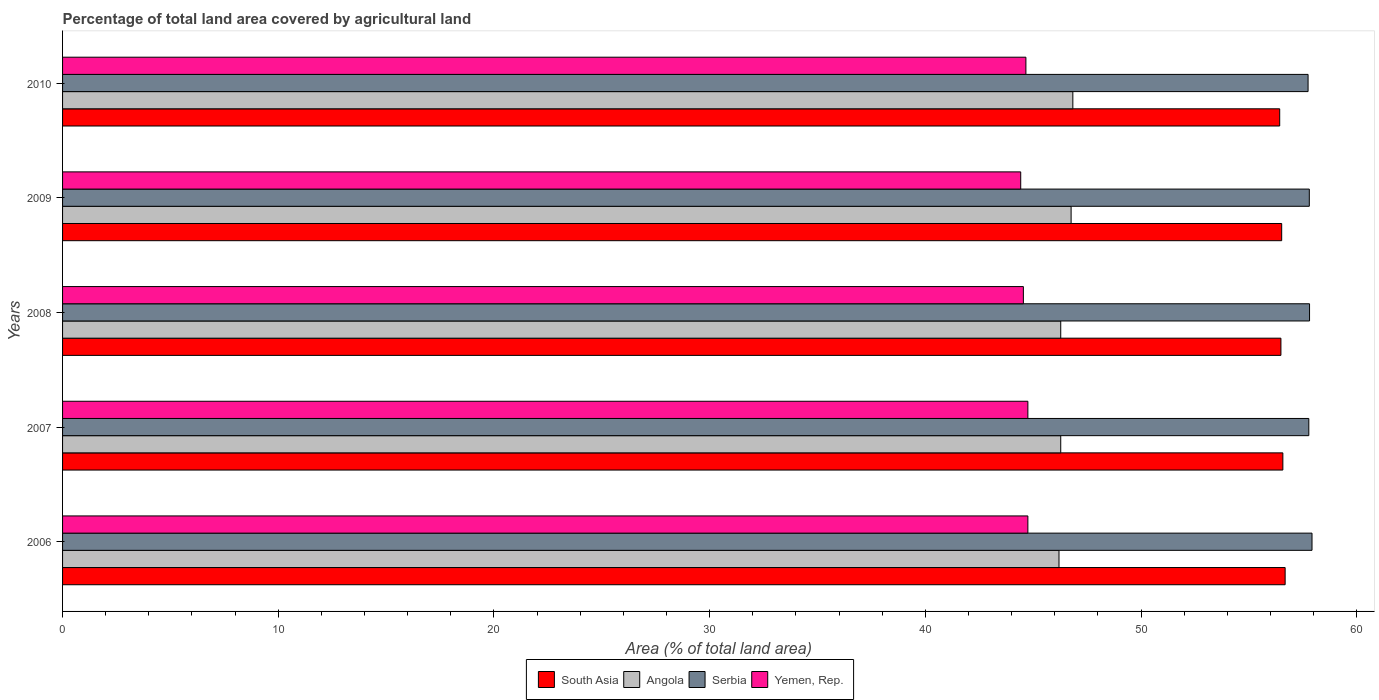How many different coloured bars are there?
Keep it short and to the point. 4. How many groups of bars are there?
Make the answer very short. 5. Are the number of bars per tick equal to the number of legend labels?
Provide a succinct answer. Yes. Are the number of bars on each tick of the Y-axis equal?
Offer a very short reply. Yes. How many bars are there on the 2nd tick from the top?
Offer a terse response. 4. How many bars are there on the 2nd tick from the bottom?
Offer a terse response. 4. In how many cases, is the number of bars for a given year not equal to the number of legend labels?
Your answer should be compact. 0. What is the percentage of agricultural land in South Asia in 2009?
Make the answer very short. 56.52. Across all years, what is the maximum percentage of agricultural land in Yemen, Rep.?
Make the answer very short. 44.75. Across all years, what is the minimum percentage of agricultural land in Angola?
Ensure brevity in your answer.  46.19. In which year was the percentage of agricultural land in Angola maximum?
Your response must be concise. 2010. In which year was the percentage of agricultural land in Yemen, Rep. minimum?
Your answer should be very brief. 2009. What is the total percentage of agricultural land in Angola in the graph?
Make the answer very short. 232.33. What is the difference between the percentage of agricultural land in Yemen, Rep. in 2006 and that in 2010?
Offer a terse response. 0.09. What is the difference between the percentage of agricultural land in Angola in 2010 and the percentage of agricultural land in Yemen, Rep. in 2008?
Your answer should be very brief. 2.29. What is the average percentage of agricultural land in Yemen, Rep. per year?
Your answer should be compact. 44.62. In the year 2007, what is the difference between the percentage of agricultural land in Serbia and percentage of agricultural land in Angola?
Keep it short and to the point. 11.5. In how many years, is the percentage of agricultural land in Angola greater than 40 %?
Provide a succinct answer. 5. What is the ratio of the percentage of agricultural land in Serbia in 2007 to that in 2008?
Provide a succinct answer. 1. Is the difference between the percentage of agricultural land in Serbia in 2006 and 2007 greater than the difference between the percentage of agricultural land in Angola in 2006 and 2007?
Make the answer very short. Yes. What is the difference between the highest and the second highest percentage of agricultural land in South Asia?
Give a very brief answer. 0.11. What is the difference between the highest and the lowest percentage of agricultural land in South Asia?
Your answer should be compact. 0.25. Is the sum of the percentage of agricultural land in Serbia in 2006 and 2009 greater than the maximum percentage of agricultural land in Angola across all years?
Offer a very short reply. Yes. Is it the case that in every year, the sum of the percentage of agricultural land in Yemen, Rep. and percentage of agricultural land in Serbia is greater than the sum of percentage of agricultural land in Angola and percentage of agricultural land in South Asia?
Offer a very short reply. Yes. What does the 2nd bar from the top in 2009 represents?
Your response must be concise. Serbia. What does the 3rd bar from the bottom in 2006 represents?
Your answer should be compact. Serbia. How many bars are there?
Keep it short and to the point. 20. How many years are there in the graph?
Your answer should be compact. 5. What is the difference between two consecutive major ticks on the X-axis?
Offer a very short reply. 10. Are the values on the major ticks of X-axis written in scientific E-notation?
Offer a terse response. No. Does the graph contain grids?
Offer a terse response. No. Where does the legend appear in the graph?
Make the answer very short. Bottom center. How are the legend labels stacked?
Your response must be concise. Horizontal. What is the title of the graph?
Offer a terse response. Percentage of total land area covered by agricultural land. Does "Costa Rica" appear as one of the legend labels in the graph?
Provide a short and direct response. No. What is the label or title of the X-axis?
Provide a short and direct response. Area (% of total land area). What is the label or title of the Y-axis?
Your answer should be compact. Years. What is the Area (% of total land area) of South Asia in 2006?
Your answer should be very brief. 56.68. What is the Area (% of total land area) of Angola in 2006?
Ensure brevity in your answer.  46.19. What is the Area (% of total land area) of Serbia in 2006?
Your answer should be compact. 57.92. What is the Area (% of total land area) of Yemen, Rep. in 2006?
Make the answer very short. 44.75. What is the Area (% of total land area) in South Asia in 2007?
Your response must be concise. 56.57. What is the Area (% of total land area) in Angola in 2007?
Your answer should be compact. 46.27. What is the Area (% of total land area) in Serbia in 2007?
Ensure brevity in your answer.  57.77. What is the Area (% of total land area) in Yemen, Rep. in 2007?
Your answer should be compact. 44.75. What is the Area (% of total land area) of South Asia in 2008?
Offer a very short reply. 56.48. What is the Area (% of total land area) of Angola in 2008?
Make the answer very short. 46.27. What is the Area (% of total land area) of Serbia in 2008?
Your response must be concise. 57.81. What is the Area (% of total land area) in Yemen, Rep. in 2008?
Your response must be concise. 44.54. What is the Area (% of total land area) of South Asia in 2009?
Make the answer very short. 56.52. What is the Area (% of total land area) in Angola in 2009?
Provide a short and direct response. 46.76. What is the Area (% of total land area) in Serbia in 2009?
Your answer should be very brief. 57.8. What is the Area (% of total land area) of Yemen, Rep. in 2009?
Keep it short and to the point. 44.42. What is the Area (% of total land area) of South Asia in 2010?
Provide a short and direct response. 56.43. What is the Area (% of total land area) in Angola in 2010?
Provide a short and direct response. 46.84. What is the Area (% of total land area) of Serbia in 2010?
Your response must be concise. 57.74. What is the Area (% of total land area) in Yemen, Rep. in 2010?
Provide a short and direct response. 44.66. Across all years, what is the maximum Area (% of total land area) of South Asia?
Your answer should be very brief. 56.68. Across all years, what is the maximum Area (% of total land area) of Angola?
Provide a succinct answer. 46.84. Across all years, what is the maximum Area (% of total land area) in Serbia?
Ensure brevity in your answer.  57.92. Across all years, what is the maximum Area (% of total land area) in Yemen, Rep.?
Your answer should be very brief. 44.75. Across all years, what is the minimum Area (% of total land area) in South Asia?
Your answer should be very brief. 56.43. Across all years, what is the minimum Area (% of total land area) in Angola?
Give a very brief answer. 46.19. Across all years, what is the minimum Area (% of total land area) of Serbia?
Provide a succinct answer. 57.74. Across all years, what is the minimum Area (% of total land area) of Yemen, Rep.?
Keep it short and to the point. 44.42. What is the total Area (% of total land area) of South Asia in the graph?
Keep it short and to the point. 282.67. What is the total Area (% of total land area) in Angola in the graph?
Ensure brevity in your answer.  232.33. What is the total Area (% of total land area) in Serbia in the graph?
Make the answer very short. 289.05. What is the total Area (% of total land area) of Yemen, Rep. in the graph?
Offer a terse response. 223.12. What is the difference between the Area (% of total land area) of South Asia in 2006 and that in 2007?
Your answer should be very brief. 0.11. What is the difference between the Area (% of total land area) in Angola in 2006 and that in 2007?
Your response must be concise. -0.08. What is the difference between the Area (% of total land area) in Serbia in 2006 and that in 2007?
Offer a very short reply. 0.15. What is the difference between the Area (% of total land area) of Yemen, Rep. in 2006 and that in 2007?
Give a very brief answer. 0. What is the difference between the Area (% of total land area) of South Asia in 2006 and that in 2008?
Provide a succinct answer. 0.2. What is the difference between the Area (% of total land area) of Angola in 2006 and that in 2008?
Keep it short and to the point. -0.08. What is the difference between the Area (% of total land area) in Serbia in 2006 and that in 2008?
Your answer should be very brief. 0.11. What is the difference between the Area (% of total land area) in Yemen, Rep. in 2006 and that in 2008?
Give a very brief answer. 0.21. What is the difference between the Area (% of total land area) of South Asia in 2006 and that in 2009?
Make the answer very short. 0.16. What is the difference between the Area (% of total land area) in Angola in 2006 and that in 2009?
Provide a short and direct response. -0.56. What is the difference between the Area (% of total land area) of Serbia in 2006 and that in 2009?
Keep it short and to the point. 0.13. What is the difference between the Area (% of total land area) in Yemen, Rep. in 2006 and that in 2009?
Offer a terse response. 0.33. What is the difference between the Area (% of total land area) of South Asia in 2006 and that in 2010?
Provide a short and direct response. 0.25. What is the difference between the Area (% of total land area) in Angola in 2006 and that in 2010?
Offer a terse response. -0.64. What is the difference between the Area (% of total land area) in Serbia in 2006 and that in 2010?
Your answer should be compact. 0.18. What is the difference between the Area (% of total land area) in Yemen, Rep. in 2006 and that in 2010?
Offer a very short reply. 0.09. What is the difference between the Area (% of total land area) of South Asia in 2007 and that in 2008?
Ensure brevity in your answer.  0.09. What is the difference between the Area (% of total land area) in Serbia in 2007 and that in 2008?
Provide a succinct answer. -0.03. What is the difference between the Area (% of total land area) of Yemen, Rep. in 2007 and that in 2008?
Keep it short and to the point. 0.21. What is the difference between the Area (% of total land area) of South Asia in 2007 and that in 2009?
Your response must be concise. 0.05. What is the difference between the Area (% of total land area) of Angola in 2007 and that in 2009?
Keep it short and to the point. -0.48. What is the difference between the Area (% of total land area) of Serbia in 2007 and that in 2009?
Ensure brevity in your answer.  -0.02. What is the difference between the Area (% of total land area) in Yemen, Rep. in 2007 and that in 2009?
Ensure brevity in your answer.  0.33. What is the difference between the Area (% of total land area) of South Asia in 2007 and that in 2010?
Offer a very short reply. 0.15. What is the difference between the Area (% of total land area) of Angola in 2007 and that in 2010?
Keep it short and to the point. -0.56. What is the difference between the Area (% of total land area) of Serbia in 2007 and that in 2010?
Your response must be concise. 0.03. What is the difference between the Area (% of total land area) of Yemen, Rep. in 2007 and that in 2010?
Provide a succinct answer. 0.09. What is the difference between the Area (% of total land area) of South Asia in 2008 and that in 2009?
Provide a succinct answer. -0.04. What is the difference between the Area (% of total land area) of Angola in 2008 and that in 2009?
Offer a very short reply. -0.48. What is the difference between the Area (% of total land area) in Serbia in 2008 and that in 2009?
Provide a succinct answer. 0.01. What is the difference between the Area (% of total land area) in Yemen, Rep. in 2008 and that in 2009?
Ensure brevity in your answer.  0.12. What is the difference between the Area (% of total land area) of South Asia in 2008 and that in 2010?
Your answer should be very brief. 0.06. What is the difference between the Area (% of total land area) of Angola in 2008 and that in 2010?
Provide a succinct answer. -0.56. What is the difference between the Area (% of total land area) in Serbia in 2008 and that in 2010?
Your response must be concise. 0.07. What is the difference between the Area (% of total land area) in Yemen, Rep. in 2008 and that in 2010?
Your response must be concise. -0.12. What is the difference between the Area (% of total land area) in South Asia in 2009 and that in 2010?
Ensure brevity in your answer.  0.09. What is the difference between the Area (% of total land area) in Angola in 2009 and that in 2010?
Provide a succinct answer. -0.08. What is the difference between the Area (% of total land area) of Serbia in 2009 and that in 2010?
Provide a succinct answer. 0.06. What is the difference between the Area (% of total land area) of Yemen, Rep. in 2009 and that in 2010?
Your answer should be very brief. -0.24. What is the difference between the Area (% of total land area) of South Asia in 2006 and the Area (% of total land area) of Angola in 2007?
Keep it short and to the point. 10.4. What is the difference between the Area (% of total land area) in South Asia in 2006 and the Area (% of total land area) in Serbia in 2007?
Keep it short and to the point. -1.1. What is the difference between the Area (% of total land area) of South Asia in 2006 and the Area (% of total land area) of Yemen, Rep. in 2007?
Offer a terse response. 11.93. What is the difference between the Area (% of total land area) of Angola in 2006 and the Area (% of total land area) of Serbia in 2007?
Your answer should be compact. -11.58. What is the difference between the Area (% of total land area) in Angola in 2006 and the Area (% of total land area) in Yemen, Rep. in 2007?
Provide a succinct answer. 1.44. What is the difference between the Area (% of total land area) in Serbia in 2006 and the Area (% of total land area) in Yemen, Rep. in 2007?
Provide a succinct answer. 13.17. What is the difference between the Area (% of total land area) in South Asia in 2006 and the Area (% of total land area) in Angola in 2008?
Your answer should be compact. 10.4. What is the difference between the Area (% of total land area) in South Asia in 2006 and the Area (% of total land area) in Serbia in 2008?
Offer a very short reply. -1.13. What is the difference between the Area (% of total land area) of South Asia in 2006 and the Area (% of total land area) of Yemen, Rep. in 2008?
Make the answer very short. 12.14. What is the difference between the Area (% of total land area) of Angola in 2006 and the Area (% of total land area) of Serbia in 2008?
Your response must be concise. -11.62. What is the difference between the Area (% of total land area) in Angola in 2006 and the Area (% of total land area) in Yemen, Rep. in 2008?
Your answer should be compact. 1.65. What is the difference between the Area (% of total land area) in Serbia in 2006 and the Area (% of total land area) in Yemen, Rep. in 2008?
Provide a succinct answer. 13.38. What is the difference between the Area (% of total land area) of South Asia in 2006 and the Area (% of total land area) of Angola in 2009?
Keep it short and to the point. 9.92. What is the difference between the Area (% of total land area) in South Asia in 2006 and the Area (% of total land area) in Serbia in 2009?
Your answer should be compact. -1.12. What is the difference between the Area (% of total land area) in South Asia in 2006 and the Area (% of total land area) in Yemen, Rep. in 2009?
Give a very brief answer. 12.26. What is the difference between the Area (% of total land area) in Angola in 2006 and the Area (% of total land area) in Serbia in 2009?
Ensure brevity in your answer.  -11.6. What is the difference between the Area (% of total land area) in Angola in 2006 and the Area (% of total land area) in Yemen, Rep. in 2009?
Provide a short and direct response. 1.77. What is the difference between the Area (% of total land area) of Serbia in 2006 and the Area (% of total land area) of Yemen, Rep. in 2009?
Make the answer very short. 13.5. What is the difference between the Area (% of total land area) in South Asia in 2006 and the Area (% of total land area) in Angola in 2010?
Offer a very short reply. 9.84. What is the difference between the Area (% of total land area) in South Asia in 2006 and the Area (% of total land area) in Serbia in 2010?
Offer a terse response. -1.06. What is the difference between the Area (% of total land area) of South Asia in 2006 and the Area (% of total land area) of Yemen, Rep. in 2010?
Provide a short and direct response. 12.02. What is the difference between the Area (% of total land area) of Angola in 2006 and the Area (% of total land area) of Serbia in 2010?
Provide a succinct answer. -11.55. What is the difference between the Area (% of total land area) of Angola in 2006 and the Area (% of total land area) of Yemen, Rep. in 2010?
Your response must be concise. 1.53. What is the difference between the Area (% of total land area) in Serbia in 2006 and the Area (% of total land area) in Yemen, Rep. in 2010?
Your answer should be very brief. 13.26. What is the difference between the Area (% of total land area) of South Asia in 2007 and the Area (% of total land area) of Angola in 2008?
Your answer should be compact. 10.3. What is the difference between the Area (% of total land area) of South Asia in 2007 and the Area (% of total land area) of Serbia in 2008?
Offer a terse response. -1.24. What is the difference between the Area (% of total land area) of South Asia in 2007 and the Area (% of total land area) of Yemen, Rep. in 2008?
Ensure brevity in your answer.  12.03. What is the difference between the Area (% of total land area) in Angola in 2007 and the Area (% of total land area) in Serbia in 2008?
Offer a terse response. -11.54. What is the difference between the Area (% of total land area) in Angola in 2007 and the Area (% of total land area) in Yemen, Rep. in 2008?
Keep it short and to the point. 1.73. What is the difference between the Area (% of total land area) in Serbia in 2007 and the Area (% of total land area) in Yemen, Rep. in 2008?
Ensure brevity in your answer.  13.23. What is the difference between the Area (% of total land area) of South Asia in 2007 and the Area (% of total land area) of Angola in 2009?
Provide a short and direct response. 9.82. What is the difference between the Area (% of total land area) in South Asia in 2007 and the Area (% of total land area) in Serbia in 2009?
Your answer should be very brief. -1.23. What is the difference between the Area (% of total land area) of South Asia in 2007 and the Area (% of total land area) of Yemen, Rep. in 2009?
Your response must be concise. 12.15. What is the difference between the Area (% of total land area) of Angola in 2007 and the Area (% of total land area) of Serbia in 2009?
Give a very brief answer. -11.52. What is the difference between the Area (% of total land area) of Angola in 2007 and the Area (% of total land area) of Yemen, Rep. in 2009?
Ensure brevity in your answer.  1.85. What is the difference between the Area (% of total land area) of Serbia in 2007 and the Area (% of total land area) of Yemen, Rep. in 2009?
Your response must be concise. 13.36. What is the difference between the Area (% of total land area) in South Asia in 2007 and the Area (% of total land area) in Angola in 2010?
Your answer should be compact. 9.74. What is the difference between the Area (% of total land area) in South Asia in 2007 and the Area (% of total land area) in Serbia in 2010?
Make the answer very short. -1.17. What is the difference between the Area (% of total land area) of South Asia in 2007 and the Area (% of total land area) of Yemen, Rep. in 2010?
Offer a very short reply. 11.91. What is the difference between the Area (% of total land area) in Angola in 2007 and the Area (% of total land area) in Serbia in 2010?
Offer a terse response. -11.47. What is the difference between the Area (% of total land area) of Angola in 2007 and the Area (% of total land area) of Yemen, Rep. in 2010?
Provide a succinct answer. 1.61. What is the difference between the Area (% of total land area) in Serbia in 2007 and the Area (% of total land area) in Yemen, Rep. in 2010?
Your answer should be compact. 13.12. What is the difference between the Area (% of total land area) of South Asia in 2008 and the Area (% of total land area) of Angola in 2009?
Offer a very short reply. 9.73. What is the difference between the Area (% of total land area) in South Asia in 2008 and the Area (% of total land area) in Serbia in 2009?
Your response must be concise. -1.32. What is the difference between the Area (% of total land area) in South Asia in 2008 and the Area (% of total land area) in Yemen, Rep. in 2009?
Keep it short and to the point. 12.06. What is the difference between the Area (% of total land area) of Angola in 2008 and the Area (% of total land area) of Serbia in 2009?
Your response must be concise. -11.52. What is the difference between the Area (% of total land area) of Angola in 2008 and the Area (% of total land area) of Yemen, Rep. in 2009?
Your answer should be compact. 1.85. What is the difference between the Area (% of total land area) of Serbia in 2008 and the Area (% of total land area) of Yemen, Rep. in 2009?
Offer a terse response. 13.39. What is the difference between the Area (% of total land area) in South Asia in 2008 and the Area (% of total land area) in Angola in 2010?
Make the answer very short. 9.65. What is the difference between the Area (% of total land area) in South Asia in 2008 and the Area (% of total land area) in Serbia in 2010?
Give a very brief answer. -1.26. What is the difference between the Area (% of total land area) of South Asia in 2008 and the Area (% of total land area) of Yemen, Rep. in 2010?
Ensure brevity in your answer.  11.82. What is the difference between the Area (% of total land area) in Angola in 2008 and the Area (% of total land area) in Serbia in 2010?
Give a very brief answer. -11.47. What is the difference between the Area (% of total land area) in Angola in 2008 and the Area (% of total land area) in Yemen, Rep. in 2010?
Offer a terse response. 1.61. What is the difference between the Area (% of total land area) of Serbia in 2008 and the Area (% of total land area) of Yemen, Rep. in 2010?
Provide a short and direct response. 13.15. What is the difference between the Area (% of total land area) of South Asia in 2009 and the Area (% of total land area) of Angola in 2010?
Offer a very short reply. 9.68. What is the difference between the Area (% of total land area) of South Asia in 2009 and the Area (% of total land area) of Serbia in 2010?
Offer a very short reply. -1.22. What is the difference between the Area (% of total land area) of South Asia in 2009 and the Area (% of total land area) of Yemen, Rep. in 2010?
Provide a succinct answer. 11.86. What is the difference between the Area (% of total land area) in Angola in 2009 and the Area (% of total land area) in Serbia in 2010?
Offer a terse response. -10.99. What is the difference between the Area (% of total land area) in Angola in 2009 and the Area (% of total land area) in Yemen, Rep. in 2010?
Your response must be concise. 2.1. What is the difference between the Area (% of total land area) in Serbia in 2009 and the Area (% of total land area) in Yemen, Rep. in 2010?
Offer a terse response. 13.14. What is the average Area (% of total land area) of South Asia per year?
Your answer should be compact. 56.53. What is the average Area (% of total land area) in Angola per year?
Offer a terse response. 46.47. What is the average Area (% of total land area) of Serbia per year?
Keep it short and to the point. 57.81. What is the average Area (% of total land area) of Yemen, Rep. per year?
Offer a very short reply. 44.62. In the year 2006, what is the difference between the Area (% of total land area) in South Asia and Area (% of total land area) in Angola?
Give a very brief answer. 10.48. In the year 2006, what is the difference between the Area (% of total land area) in South Asia and Area (% of total land area) in Serbia?
Give a very brief answer. -1.25. In the year 2006, what is the difference between the Area (% of total land area) in South Asia and Area (% of total land area) in Yemen, Rep.?
Keep it short and to the point. 11.93. In the year 2006, what is the difference between the Area (% of total land area) of Angola and Area (% of total land area) of Serbia?
Your answer should be compact. -11.73. In the year 2006, what is the difference between the Area (% of total land area) in Angola and Area (% of total land area) in Yemen, Rep.?
Your answer should be compact. 1.44. In the year 2006, what is the difference between the Area (% of total land area) of Serbia and Area (% of total land area) of Yemen, Rep.?
Offer a very short reply. 13.17. In the year 2007, what is the difference between the Area (% of total land area) in South Asia and Area (% of total land area) in Angola?
Provide a succinct answer. 10.3. In the year 2007, what is the difference between the Area (% of total land area) in South Asia and Area (% of total land area) in Serbia?
Provide a succinct answer. -1.2. In the year 2007, what is the difference between the Area (% of total land area) of South Asia and Area (% of total land area) of Yemen, Rep.?
Offer a very short reply. 11.82. In the year 2007, what is the difference between the Area (% of total land area) of Angola and Area (% of total land area) of Serbia?
Offer a terse response. -11.5. In the year 2007, what is the difference between the Area (% of total land area) of Angola and Area (% of total land area) of Yemen, Rep.?
Provide a short and direct response. 1.52. In the year 2007, what is the difference between the Area (% of total land area) of Serbia and Area (% of total land area) of Yemen, Rep.?
Your answer should be compact. 13.02. In the year 2008, what is the difference between the Area (% of total land area) of South Asia and Area (% of total land area) of Angola?
Ensure brevity in your answer.  10.21. In the year 2008, what is the difference between the Area (% of total land area) of South Asia and Area (% of total land area) of Serbia?
Offer a terse response. -1.33. In the year 2008, what is the difference between the Area (% of total land area) of South Asia and Area (% of total land area) of Yemen, Rep.?
Your answer should be very brief. 11.94. In the year 2008, what is the difference between the Area (% of total land area) in Angola and Area (% of total land area) in Serbia?
Keep it short and to the point. -11.54. In the year 2008, what is the difference between the Area (% of total land area) in Angola and Area (% of total land area) in Yemen, Rep.?
Make the answer very short. 1.73. In the year 2008, what is the difference between the Area (% of total land area) in Serbia and Area (% of total land area) in Yemen, Rep.?
Offer a very short reply. 13.27. In the year 2009, what is the difference between the Area (% of total land area) in South Asia and Area (% of total land area) in Angola?
Ensure brevity in your answer.  9.76. In the year 2009, what is the difference between the Area (% of total land area) in South Asia and Area (% of total land area) in Serbia?
Make the answer very short. -1.28. In the year 2009, what is the difference between the Area (% of total land area) in South Asia and Area (% of total land area) in Yemen, Rep.?
Your answer should be compact. 12.1. In the year 2009, what is the difference between the Area (% of total land area) of Angola and Area (% of total land area) of Serbia?
Provide a succinct answer. -11.04. In the year 2009, what is the difference between the Area (% of total land area) of Angola and Area (% of total land area) of Yemen, Rep.?
Keep it short and to the point. 2.34. In the year 2009, what is the difference between the Area (% of total land area) of Serbia and Area (% of total land area) of Yemen, Rep.?
Your answer should be compact. 13.38. In the year 2010, what is the difference between the Area (% of total land area) in South Asia and Area (% of total land area) in Angola?
Offer a terse response. 9.59. In the year 2010, what is the difference between the Area (% of total land area) in South Asia and Area (% of total land area) in Serbia?
Ensure brevity in your answer.  -1.31. In the year 2010, what is the difference between the Area (% of total land area) of South Asia and Area (% of total land area) of Yemen, Rep.?
Give a very brief answer. 11.77. In the year 2010, what is the difference between the Area (% of total land area) in Angola and Area (% of total land area) in Serbia?
Give a very brief answer. -10.9. In the year 2010, what is the difference between the Area (% of total land area) in Angola and Area (% of total land area) in Yemen, Rep.?
Keep it short and to the point. 2.18. In the year 2010, what is the difference between the Area (% of total land area) of Serbia and Area (% of total land area) of Yemen, Rep.?
Your answer should be compact. 13.08. What is the ratio of the Area (% of total land area) of South Asia in 2006 to that in 2007?
Make the answer very short. 1. What is the ratio of the Area (% of total land area) of Yemen, Rep. in 2006 to that in 2007?
Make the answer very short. 1. What is the ratio of the Area (% of total land area) of Angola in 2006 to that in 2008?
Offer a very short reply. 1. What is the ratio of the Area (% of total land area) of Yemen, Rep. in 2006 to that in 2008?
Ensure brevity in your answer.  1. What is the ratio of the Area (% of total land area) in South Asia in 2006 to that in 2009?
Your answer should be compact. 1. What is the ratio of the Area (% of total land area) in Serbia in 2006 to that in 2009?
Ensure brevity in your answer.  1. What is the ratio of the Area (% of total land area) of Yemen, Rep. in 2006 to that in 2009?
Provide a succinct answer. 1.01. What is the ratio of the Area (% of total land area) in South Asia in 2006 to that in 2010?
Your answer should be compact. 1. What is the ratio of the Area (% of total land area) of Angola in 2006 to that in 2010?
Provide a short and direct response. 0.99. What is the ratio of the Area (% of total land area) of Serbia in 2006 to that in 2010?
Your answer should be very brief. 1. What is the ratio of the Area (% of total land area) of South Asia in 2007 to that in 2008?
Your response must be concise. 1. What is the ratio of the Area (% of total land area) in Angola in 2007 to that in 2008?
Your answer should be very brief. 1. What is the ratio of the Area (% of total land area) of South Asia in 2007 to that in 2009?
Give a very brief answer. 1. What is the ratio of the Area (% of total land area) in Yemen, Rep. in 2007 to that in 2009?
Offer a very short reply. 1.01. What is the ratio of the Area (% of total land area) in South Asia in 2007 to that in 2010?
Your answer should be very brief. 1. What is the ratio of the Area (% of total land area) in Serbia in 2007 to that in 2010?
Your answer should be compact. 1. What is the ratio of the Area (% of total land area) of South Asia in 2008 to that in 2009?
Your response must be concise. 1. What is the ratio of the Area (% of total land area) in Angola in 2008 to that in 2009?
Make the answer very short. 0.99. What is the ratio of the Area (% of total land area) in Yemen, Rep. in 2008 to that in 2009?
Your answer should be very brief. 1. What is the ratio of the Area (% of total land area) in South Asia in 2009 to that in 2010?
Offer a terse response. 1. What is the ratio of the Area (% of total land area) in Yemen, Rep. in 2009 to that in 2010?
Your response must be concise. 0.99. What is the difference between the highest and the second highest Area (% of total land area) in South Asia?
Give a very brief answer. 0.11. What is the difference between the highest and the second highest Area (% of total land area) in Angola?
Offer a terse response. 0.08. What is the difference between the highest and the second highest Area (% of total land area) of Serbia?
Your answer should be compact. 0.11. What is the difference between the highest and the second highest Area (% of total land area) of Yemen, Rep.?
Keep it short and to the point. 0. What is the difference between the highest and the lowest Area (% of total land area) of South Asia?
Ensure brevity in your answer.  0.25. What is the difference between the highest and the lowest Area (% of total land area) of Angola?
Provide a succinct answer. 0.64. What is the difference between the highest and the lowest Area (% of total land area) in Serbia?
Offer a very short reply. 0.18. What is the difference between the highest and the lowest Area (% of total land area) in Yemen, Rep.?
Keep it short and to the point. 0.33. 